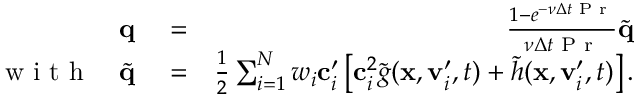Convert formula to latex. <formula><loc_0><loc_0><loc_500><loc_500>\begin{array} { r l r } { \mathbf q } & = } & { \frac { 1 - e ^ { - \nu \Delta t P r } } { \nu \Delta t P r } \widetilde { q } } \\ { w i t h \quad \widetilde { q } } & = } & { \frac { 1 } { 2 } \sum _ { i = 1 } ^ { N } w _ { i } \mathbf c _ { i } ^ { \prime } \left [ \mathbf c _ { i } ^ { 2 } \widetilde { g } ( \mathbf x , \mathbf v _ { i } ^ { \prime } , t ) + \widetilde { h } ( \mathbf x , \mathbf v _ { i } ^ { \prime } , t ) \right ] . } \end{array}</formula> 